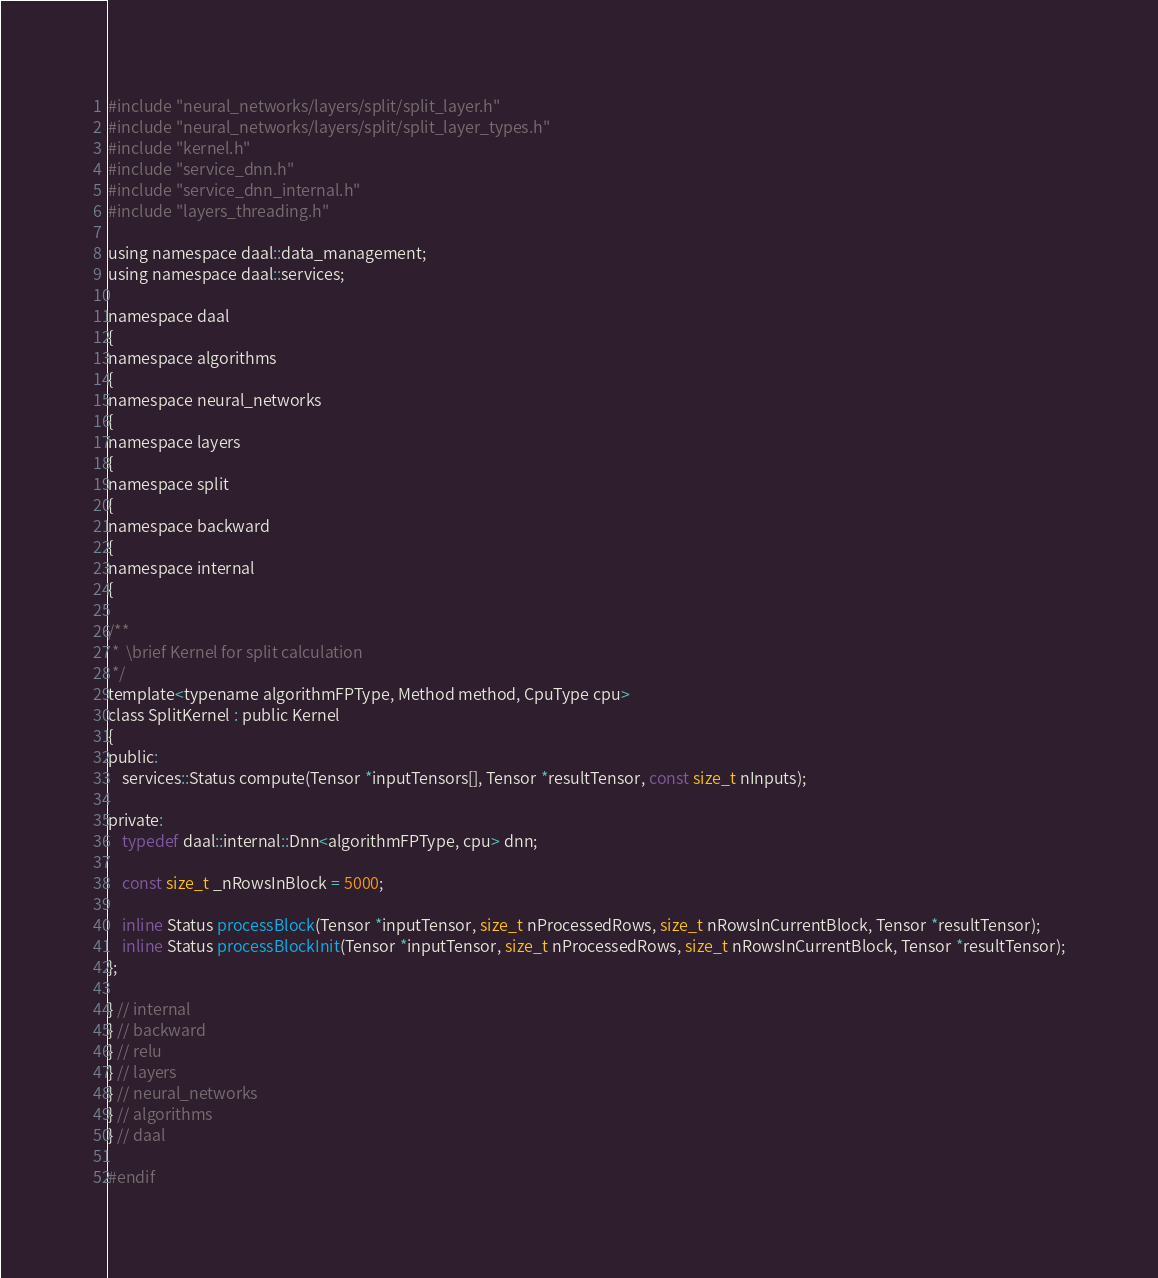<code> <loc_0><loc_0><loc_500><loc_500><_C_>#include "neural_networks/layers/split/split_layer.h"
#include "neural_networks/layers/split/split_layer_types.h"
#include "kernel.h"
#include "service_dnn.h"
#include "service_dnn_internal.h"
#include "layers_threading.h"

using namespace daal::data_management;
using namespace daal::services;

namespace daal
{
namespace algorithms
{
namespace neural_networks
{
namespace layers
{
namespace split
{
namespace backward
{
namespace internal
{

/**
 *  \brief Kernel for split calculation
 */
template<typename algorithmFPType, Method method, CpuType cpu>
class SplitKernel : public Kernel
{
public:
    services::Status compute(Tensor *inputTensors[], Tensor *resultTensor, const size_t nInputs);

private:
    typedef daal::internal::Dnn<algorithmFPType, cpu> dnn;

    const size_t _nRowsInBlock = 5000;

    inline Status processBlock(Tensor *inputTensor, size_t nProcessedRows, size_t nRowsInCurrentBlock, Tensor *resultTensor);
    inline Status processBlockInit(Tensor *inputTensor, size_t nProcessedRows, size_t nRowsInCurrentBlock, Tensor *resultTensor);
};

} // internal
} // backward
} // relu
} // layers
} // neural_networks
} // algorithms
} // daal

#endif
</code> 